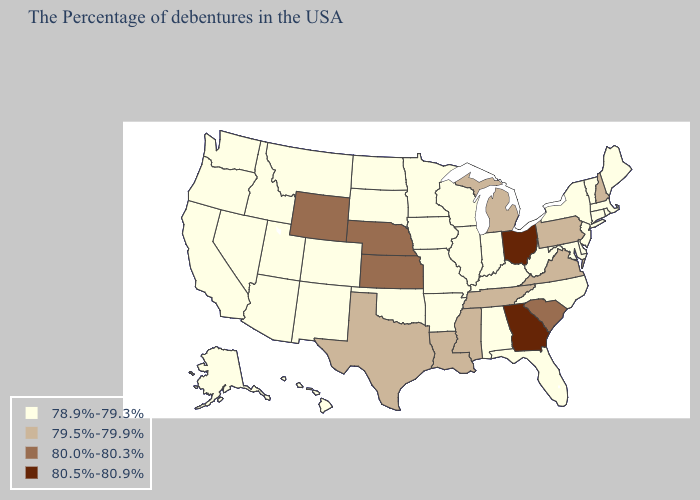Does Georgia have the highest value in the USA?
Write a very short answer. Yes. Which states have the lowest value in the South?
Keep it brief. Delaware, Maryland, North Carolina, West Virginia, Florida, Kentucky, Alabama, Arkansas, Oklahoma. What is the value of Michigan?
Short answer required. 79.5%-79.9%. What is the value of Utah?
Give a very brief answer. 78.9%-79.3%. Which states hav the highest value in the MidWest?
Concise answer only. Ohio. Which states hav the highest value in the West?
Be succinct. Wyoming. Does the first symbol in the legend represent the smallest category?
Short answer required. Yes. Name the states that have a value in the range 80.5%-80.9%?
Keep it brief. Ohio, Georgia. What is the value of Delaware?
Quick response, please. 78.9%-79.3%. Among the states that border Wisconsin , does Iowa have the lowest value?
Write a very short answer. Yes. Does South Carolina have the highest value in the USA?
Quick response, please. No. Which states hav the highest value in the MidWest?
Answer briefly. Ohio. Name the states that have a value in the range 78.9%-79.3%?
Quick response, please. Maine, Massachusetts, Rhode Island, Vermont, Connecticut, New York, New Jersey, Delaware, Maryland, North Carolina, West Virginia, Florida, Kentucky, Indiana, Alabama, Wisconsin, Illinois, Missouri, Arkansas, Minnesota, Iowa, Oklahoma, South Dakota, North Dakota, Colorado, New Mexico, Utah, Montana, Arizona, Idaho, Nevada, California, Washington, Oregon, Alaska, Hawaii. Name the states that have a value in the range 78.9%-79.3%?
Keep it brief. Maine, Massachusetts, Rhode Island, Vermont, Connecticut, New York, New Jersey, Delaware, Maryland, North Carolina, West Virginia, Florida, Kentucky, Indiana, Alabama, Wisconsin, Illinois, Missouri, Arkansas, Minnesota, Iowa, Oklahoma, South Dakota, North Dakota, Colorado, New Mexico, Utah, Montana, Arizona, Idaho, Nevada, California, Washington, Oregon, Alaska, Hawaii. Is the legend a continuous bar?
Write a very short answer. No. 